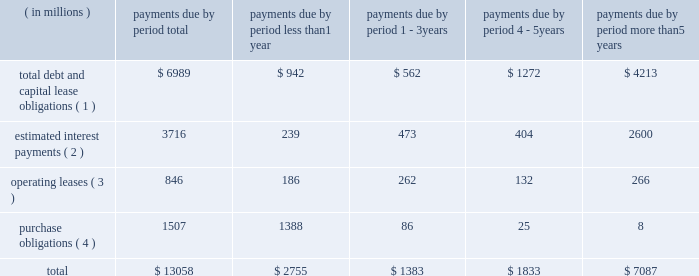Bhge 2018 form 10-k | 41 estimate would equal up to 5% ( 5 % ) of annual revenue .
The expenditures are expected to be used primarily for normal , recurring items necessary to support our business .
We also anticipate making income tax payments in the range of $ 425 million to $ 475 million in 2019 .
Contractual obligations in the table below , we set forth our contractual obligations as of december 31 , 2018 .
Certain amounts included in this table are based on our estimates and assumptions about these obligations , including their duration , anticipated actions by third parties and other factors .
The contractual obligations we will actually pay in future periods may vary from those reflected in the table because the estimates and assumptions are subjective. .
( 1 ) amounts represent the expected cash payments for the principal amounts related to our debt , including capital lease obligations .
Amounts for debt do not include any deferred issuance costs or unamortized discounts or premiums including step up in the value of the debt on the acquisition of baker hughes .
Expected cash payments for interest are excluded from these amounts .
Total debt and capital lease obligations includes $ 896 million payable to ge and its affiliates .
As there is no fixed payment schedule on the amount payable to ge and its affiliates we have classified it as payable in less than one year .
( 2 ) amounts represent the expected cash payments for interest on our long-term debt and capital lease obligations .
( 3 ) amounts represent the future minimum payments under noncancelable operating leases with initial or remaining terms of one year or more .
We enter into operating leases , some of which include renewal options , however , we have excluded renewal options from the table above unless it is anticipated that we will exercise such renewals .
( 4 ) purchase obligations include expenditures for capital assets for 2019 as well as agreements to purchase goods or services that are enforceable and legally binding and that specify all significant terms , including : fixed or minimum quantities to be purchased ; fixed , minimum or variable price provisions ; and the approximate timing of the transaction .
Due to the uncertainty with respect to the timing of potential future cash outflows associated with our uncertain tax positions , we are unable to make reasonable estimates of the period of cash settlement , if any , to the respective taxing authorities .
Therefore , $ 597 million in uncertain tax positions , including interest and penalties , have been excluded from the contractual obligations table above .
See "note 12 .
Income taxes" of the notes to consolidated and combined financial statements in item 8 herein for further information .
We have certain defined benefit pension and other post-retirement benefit plans covering certain of our u.s .
And international employees .
During 2018 , we made contributions and paid direct benefits of approximately $ 72 million in connection with those plans , and we anticipate funding approximately $ 41 million during 2019 .
Amounts for pension funding obligations are based on assumptions that are subject to change , therefore , we are currently not able to reasonably estimate our contribution figures after 2019 .
See "note 11 .
Employee benefit plans" of the notes to consolidated and combined financial statements in item 8 herein for further information .
Off-balance sheet arrangements in the normal course of business with customers , vendors and others , we have entered into off-balance sheet arrangements , such as surety bonds for performance , letters of credit and other bank issued guarantees , which totaled approximately $ 3.6 billion at december 31 , 2018 .
It is not practicable to estimate the fair value of these financial instruments .
None of the off-balance sheet arrangements either has , or is likely to have , a material effect on our consolidated and combined financial statements. .
What are the combined total operating leases and purchase obligations as a percentage of the total payments due? 
Computations: ((846 + 1507) / 13058)
Answer: 0.1802. 